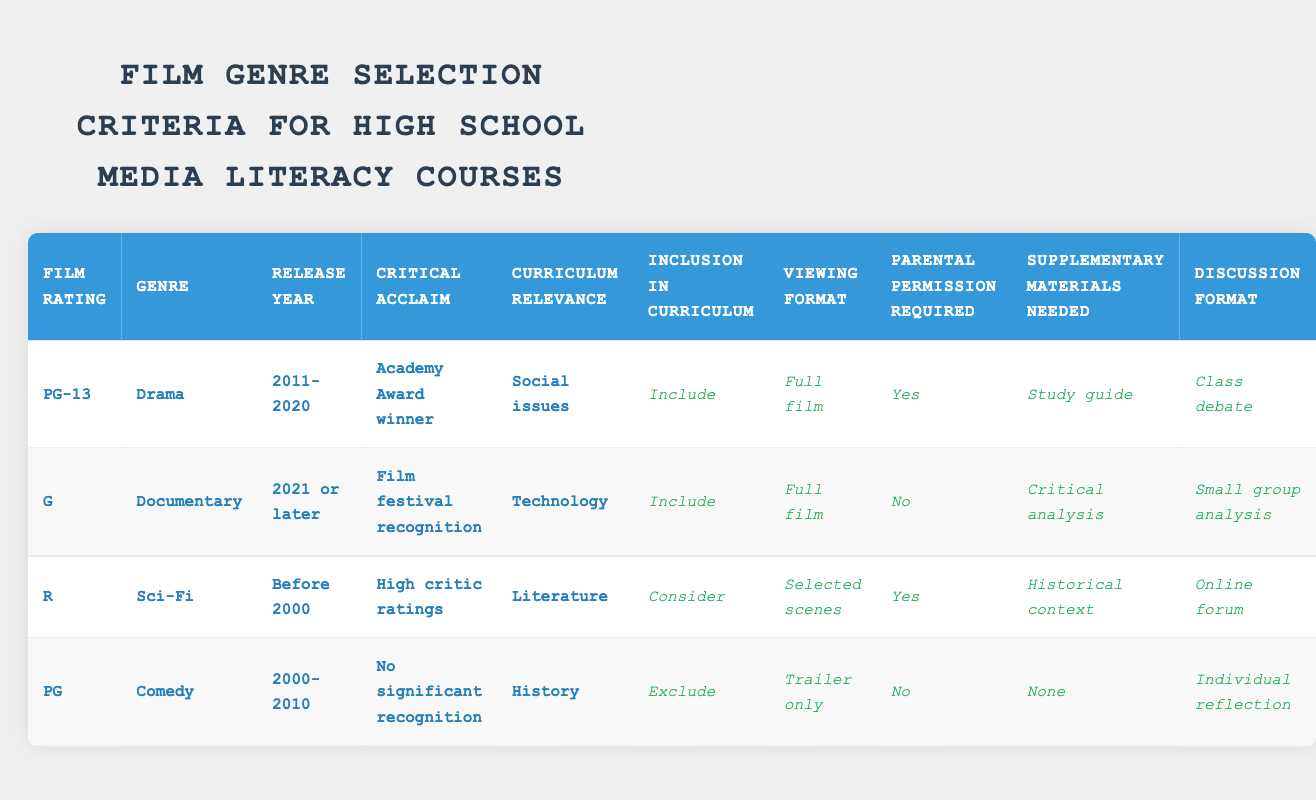What is the inclusion status for the PG-13 Drama released between 2011 and 2020? The table shows that for the conditions of Film rating PG-13, Genre Drama, Release year 2011-2020, the action specified is "Include."
Answer: Include Which genre requires parental permission in the curriculum? The rules indicate that both the R Sci-Fi (before 2000) and PG-13 Drama (2011-2020) require parental permission, as noted by "Yes" in those rows.
Answer: R Sci-Fi and PG-13 Drama How many films in the table are included in the curriculum? By reviewing the table, the two actions marked as "Include" are for the PG-13 Drama and G Documentary, so there are 2 films included in the curriculum.
Answer: 2 For which rating is the viewing format "Trailer only"? The viewing format "Trailer only" is associated with the PG Comedy released from 2000 to 2010, as specified in its corresponding row.
Answer: PG What are the supplementary materials needed for the R Sci-Fi film? The R Sci-Fi film (before 2000) requires "Historical context" as its supplementary material needed, as listed in the row for that film.
Answer: Historical context How does the selection of films differ in viewing format between films included and those considered? The films included (PG-13 Drama and G Documentary) are designated for "Full film," while the film under consideration (R Sci-Fi) is specified for "Selected scenes." This indicates a difference in how thoroughly these films are expected to be viewed in the curriculum.
Answer: Full film vs. Selected scenes Is there any film that does not require parental permission? Yes, the G Documentary (2021 or later) does not require parental permission, as indicated by "No" in its row.
Answer: Yes What type of discussion format is suggested for the G Documentary? According to the table, the G Documentary proposed for inclusion in the curriculum suggests a "Small group analysis" as the discussion format.
Answer: Small group analysis If the PG Comedy were to be included, what would be the viewing format? The table specifies that if the PG Comedy were included, the viewing format would be "Trailer only," based on its defined conditions.
Answer: Trailer only 